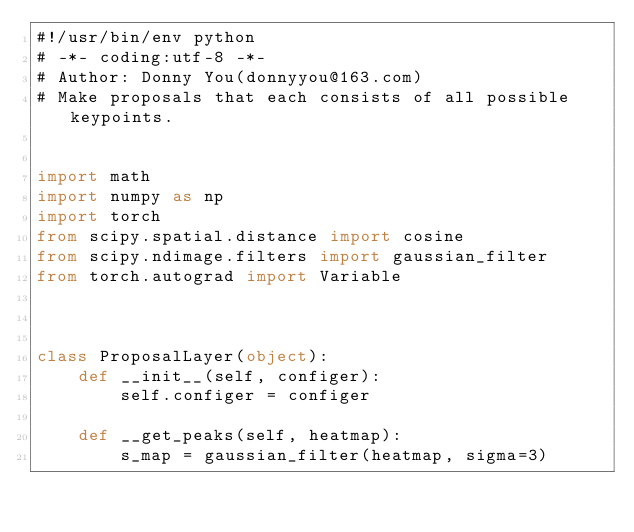Convert code to text. <code><loc_0><loc_0><loc_500><loc_500><_Python_>#!/usr/bin/env python
# -*- coding:utf-8 -*-
# Author: Donny You(donnyyou@163.com)
# Make proposals that each consists of all possible keypoints.


import math
import numpy as np
import torch
from scipy.spatial.distance import cosine
from scipy.ndimage.filters import gaussian_filter
from torch.autograd import Variable



class ProposalLayer(object):
    def __init__(self, configer):
        self.configer = configer

    def __get_peaks(self, heatmap):
        s_map = gaussian_filter(heatmap, sigma=3)</code> 